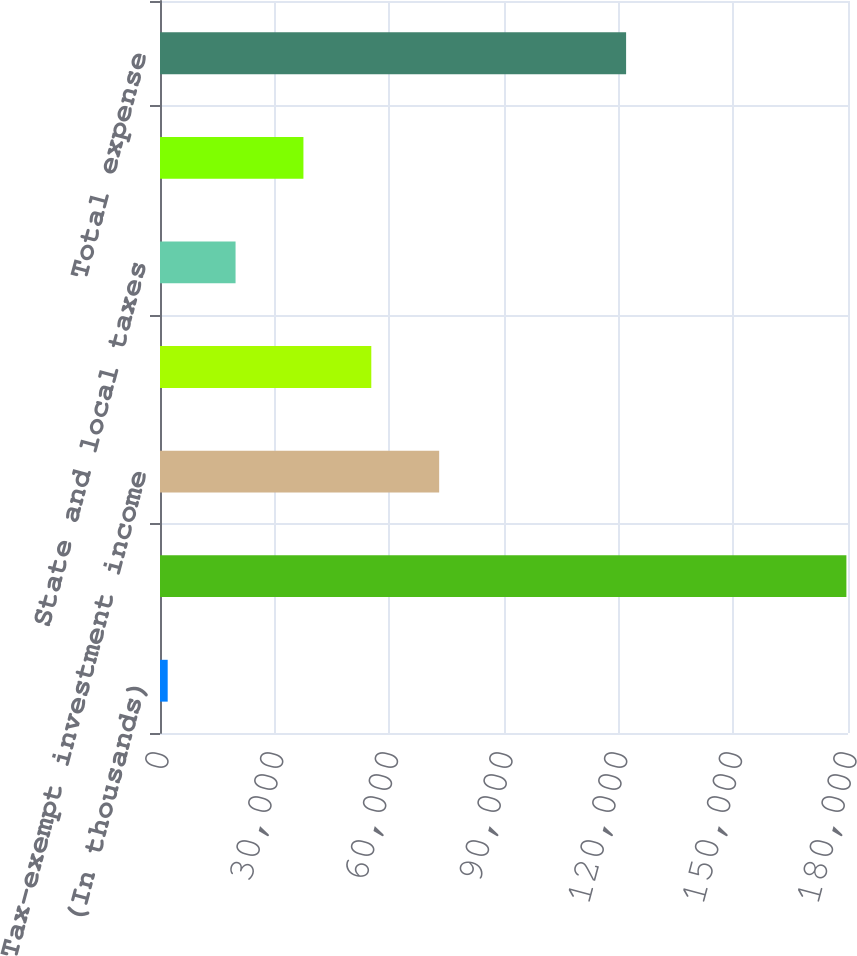Convert chart to OTSL. <chart><loc_0><loc_0><loc_500><loc_500><bar_chart><fcel>(In thousands)<fcel>Computed expected tax expense<fcel>Tax-exempt investment income<fcel>Impact of lower foreign tax<fcel>State and local taxes<fcel>Other net<fcel>Total expense<nl><fcel>2011<fcel>179580<fcel>73038.6<fcel>55281.7<fcel>19767.9<fcel>37524.8<fcel>121945<nl></chart> 